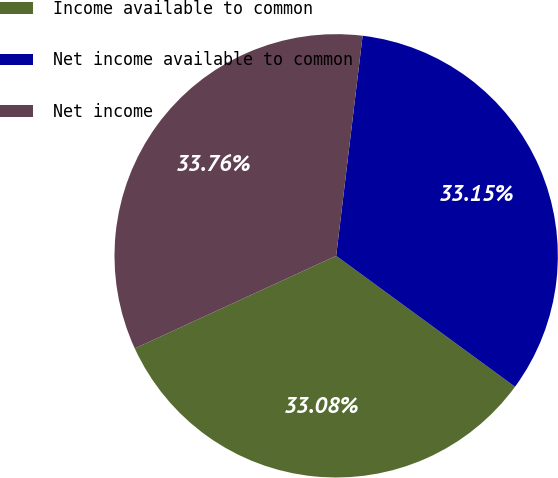Convert chart to OTSL. <chart><loc_0><loc_0><loc_500><loc_500><pie_chart><fcel>Income available to common<fcel>Net income available to common<fcel>Net income<nl><fcel>33.08%<fcel>33.15%<fcel>33.76%<nl></chart> 